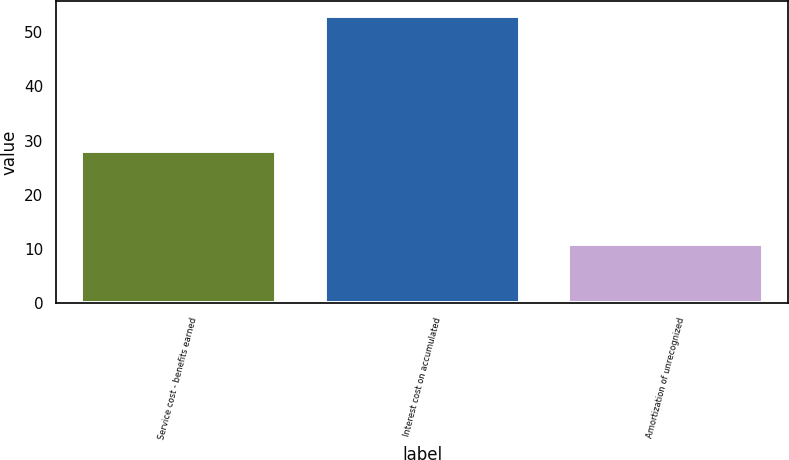Convert chart to OTSL. <chart><loc_0><loc_0><loc_500><loc_500><bar_chart><fcel>Service cost - benefits earned<fcel>Interest cost on accumulated<fcel>Amortization of unrecognized<nl><fcel>28<fcel>53<fcel>11<nl></chart> 